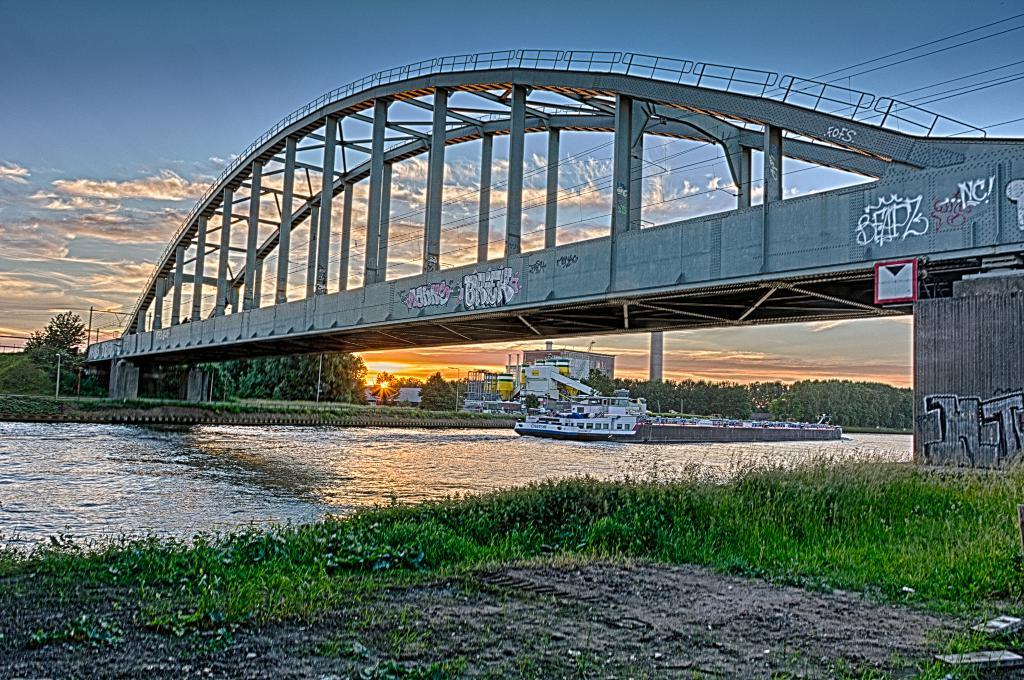What is the main subject of the image? There is a ship on the water in the image. What type of vegetation can be seen in the image? There is grass in the image. What architectural feature is present in the image? There is a bridge in the image. What can be seen in the background of the image? Trees, poles, and the sky are visible in the background of the image. What is the condition of the sky in the image? Clouds are present in the sky in the image. How many sacks of loss can be seen in the image? There is no mention of sacks or loss in the image; it features a ship on the water, grass, a bridge, trees, poles, and a sky with clouds. 